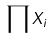<formula> <loc_0><loc_0><loc_500><loc_500>\prod X _ { i }</formula> 